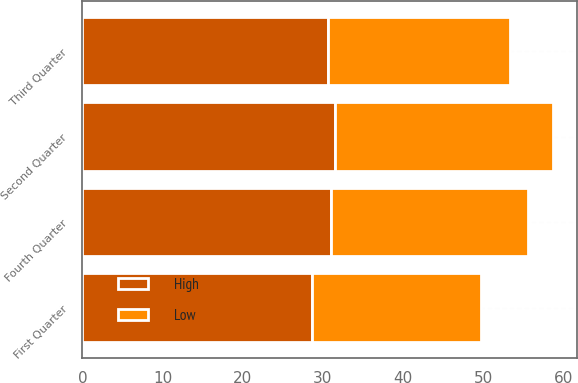Convert chart. <chart><loc_0><loc_0><loc_500><loc_500><stacked_bar_chart><ecel><fcel>First Quarter<fcel>Second Quarter<fcel>Third Quarter<fcel>Fourth Quarter<nl><fcel>High<fcel>28.67<fcel>31.48<fcel>30.66<fcel>30.98<nl><fcel>Low<fcel>21.01<fcel>27.24<fcel>22.66<fcel>24.55<nl></chart> 